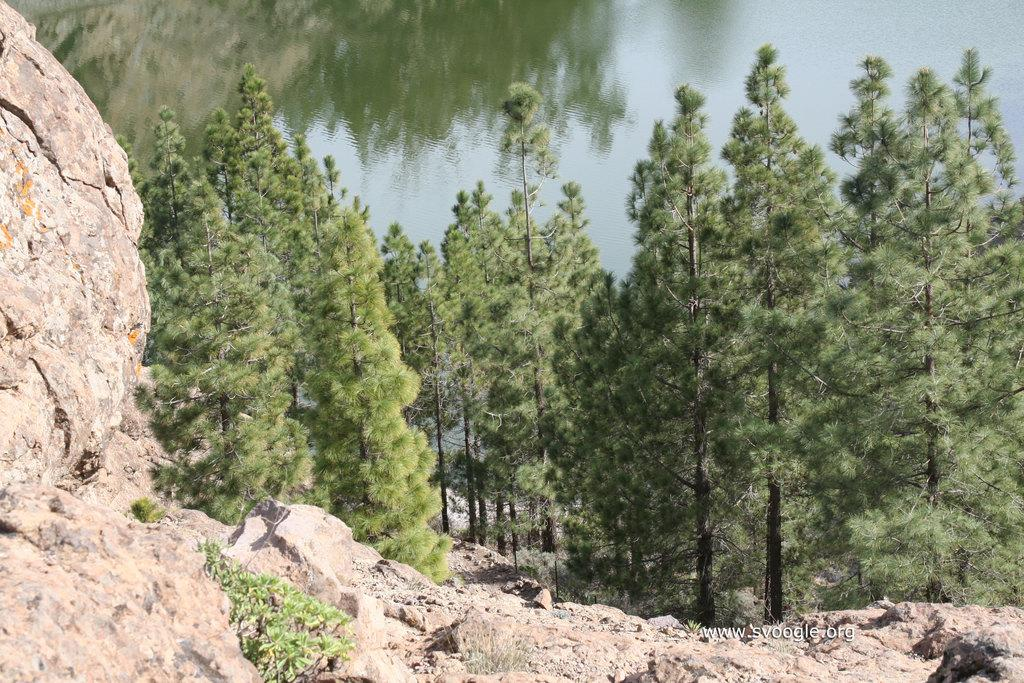What type of natural elements can be seen in the image? There are rocks and trees visible in the image. What can be seen flowing or standing still in the image? There is water visible in the image. Is there any indication of the image's origin or ownership? Yes, there is a watermark on the image. What type of dirt can be seen on the runway in the image? There is no runway or dirt present in the image; it features rocks, trees, and water. How can you get the attention of the person in the image? There is no person present in the image to get their attention. 